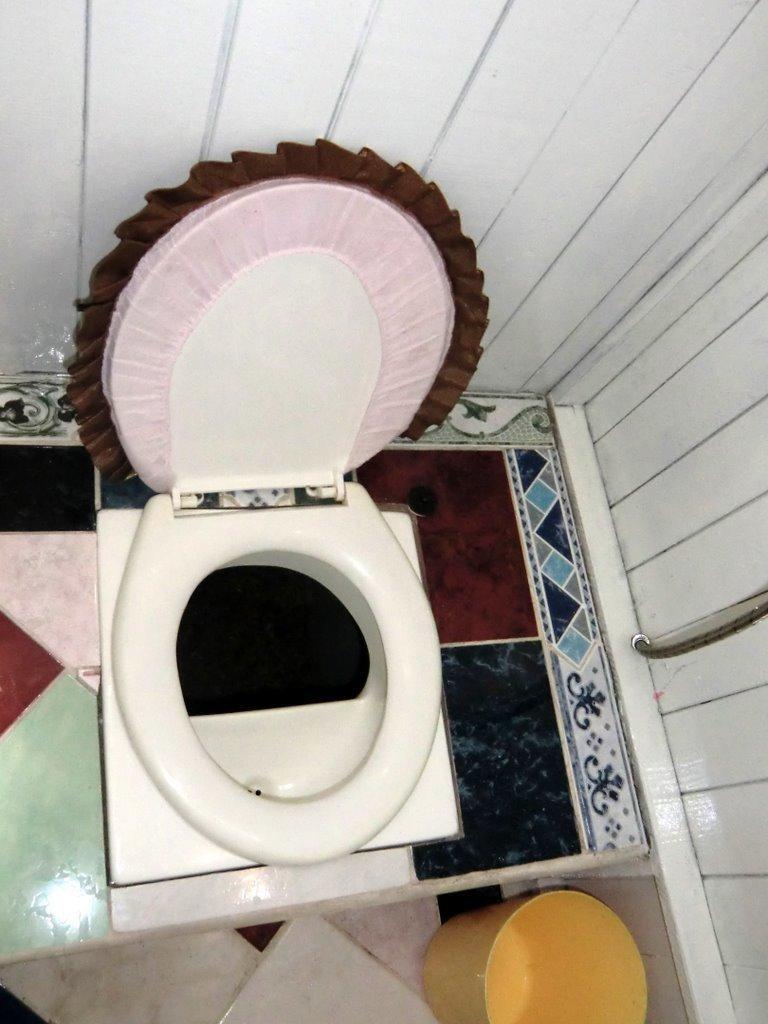Describe this image in one or two sentences. Here we can see commode and there is a bucket at the bottom and we can see tiles and this is a a pipe on the right side and this is a wall. 